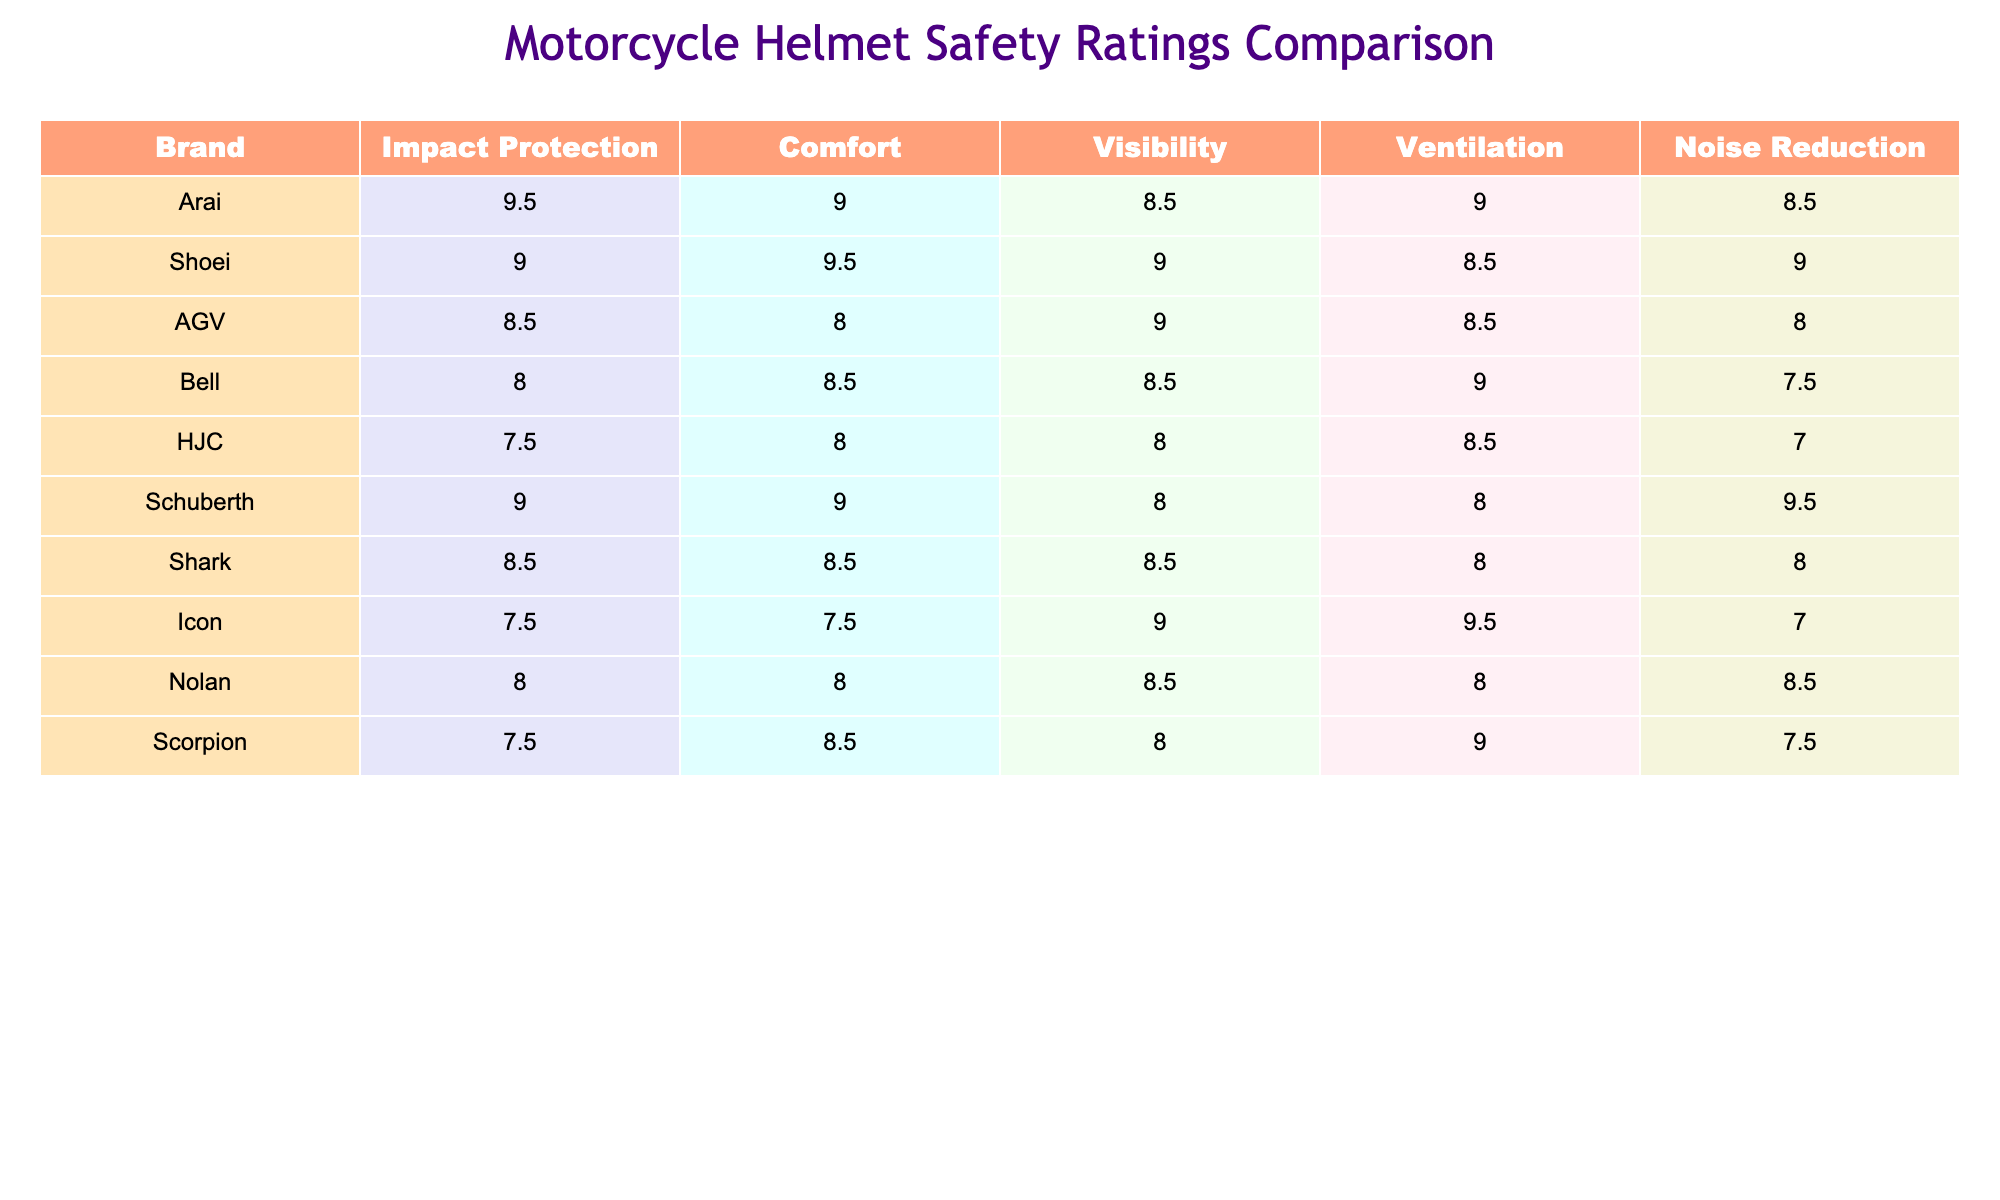What brand has the highest impact protection rating? Arai has the highest impact protection rating of 9.5. I found this by scanning the "Impact Protection" column and identifying the maximum value.
Answer: Arai Which brand has the lowest noise reduction rating? Icon has the lowest noise reduction rating of 7.0. I looked through the "Noise Reduction" column and noted the smallest number present.
Answer: Icon What is the average comfort rating across all brands? The comfort ratings are 9.0, 9.5, 8.0, 8.5, 8.0, 9.0, 8.5, 7.5, 8.0, and 8.5, giving a total of 85 combined, and with 10 brands, the average is 85/10 = 8.5.
Answer: 8.5 Which brand(s) have a visibility rating of 9.0 or higher? Brands with a visibility rating of 9.0 or higher include AGV, Shoei, and Icon. I filtered the "Visibility" column for values meeting or exceeding 9.0.
Answer: AGV, Shoei, Icon Is Schuberth's impact protection rating greater than Bell's? Yes, Schuberth's impact protection rating is 9.0, while Bell's is 8.0, making Schuberth's rating greater. I compared the two specific ratings to answer.
Answer: Yes Calculate the sum of the comfort ratings for all brands. Summing up the comfort ratings gives: 9.0 + 9.5 + 8.0 + 8.5 + 8.0 + 9.0 + 8.5 + 7.5 + 8.0 + 8.5 = 86.
Answer: 86 Which brand has better ventilation: Bell or HJC? Bell has a ventilation rating of 9.0, while HJC has 8.5. Comparing the two values, Bell has the higher rating.
Answer: Bell Are there any brands with both a comfort and impact protection rating of 9.0 or higher? Yes, Arai and Shoei both have a comfort rating of 9.0 or higher, with Arai at 9.0 and impact protection rated at 9.5, and Shoei with both ratings at 9.0 or higher. I reviewed the relevant columns for these conditions.
Answer: Yes Which brand has the highest overall performance based on combined rankings? Arai appears to have the highest performance with an overall score of 9.5 for impact protection, 9.0 for comfort, 8.5 for visibility, 9.0 for ventilation, and 8.5 for noise reduction, making it the top performer. I considered the values of all the ratings together for a summary conclusion.
Answer: Arai 